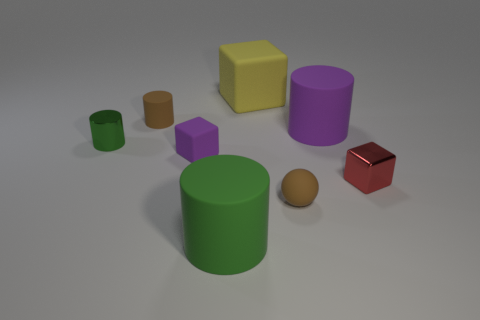Subtract all metallic blocks. How many blocks are left? 2 Subtract all purple blocks. How many blocks are left? 2 Add 1 red rubber objects. How many objects exist? 9 Subtract all balls. How many objects are left? 7 Subtract 0 blue cylinders. How many objects are left? 8 Subtract 1 spheres. How many spheres are left? 0 Subtract all cyan blocks. Subtract all purple cylinders. How many blocks are left? 3 Subtract all red blocks. How many purple cylinders are left? 1 Subtract all big red balls. Subtract all large yellow rubber objects. How many objects are left? 7 Add 8 large green cylinders. How many large green cylinders are left? 9 